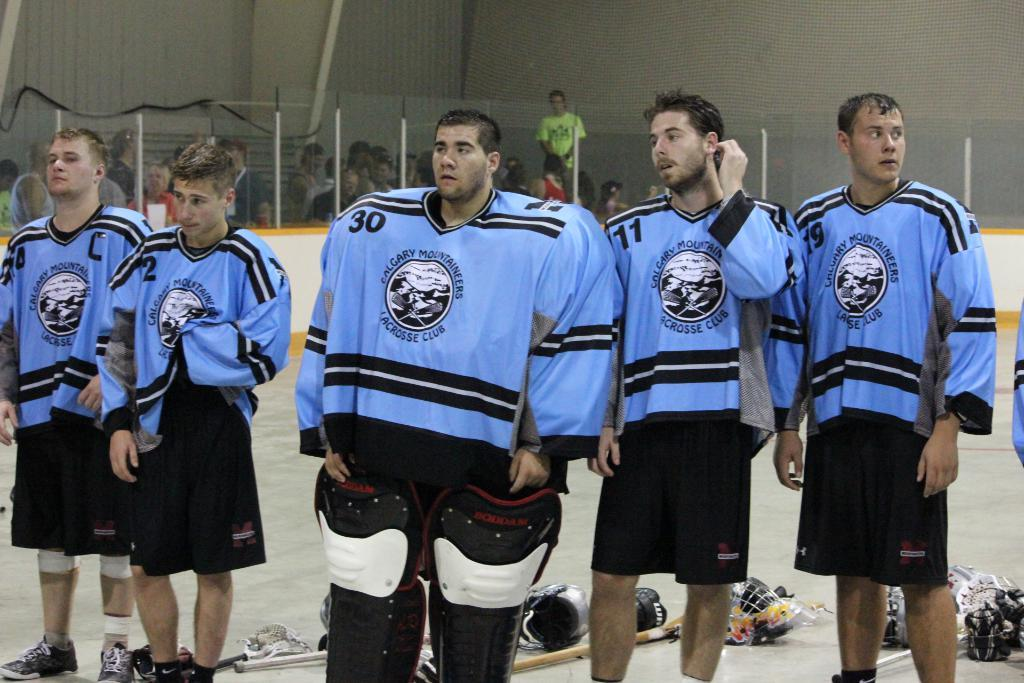<image>
Give a short and clear explanation of the subsequent image. A man in a hockey uniform has the number 30 on the front of it. 